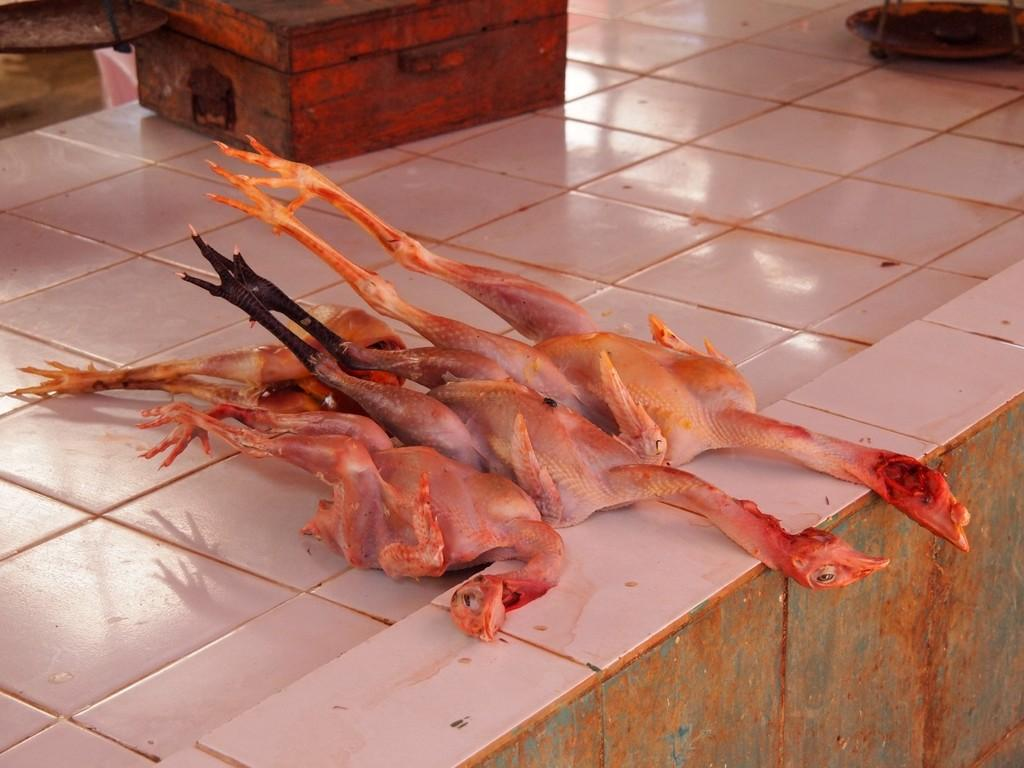What is the main structure in the center of the image? There is a platform in the center of the image. What type of animals are on the platform? Dressed chickens are present on the platform. Are there any other objects on the platform besides the chickens? Yes, there are a few other objects on the platform. What does the person's arm look like in the morning in the image? There is no person or arm visible in the image; it only features a platform with dressed chickens and a few other objects. 